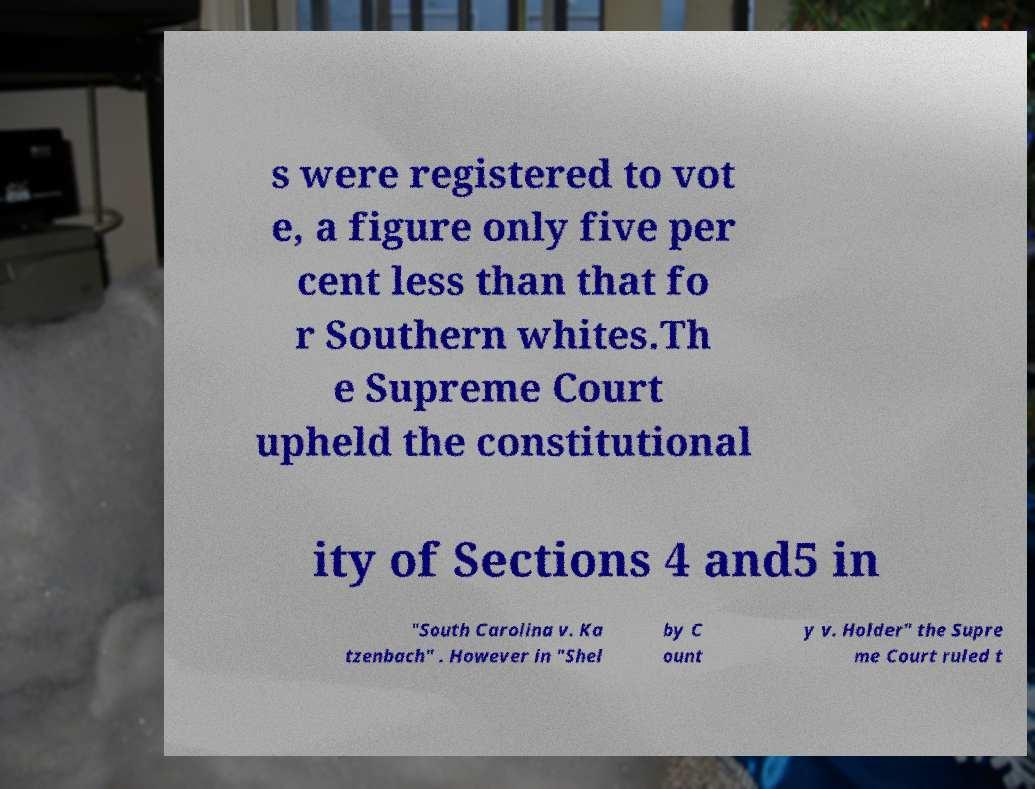Can you read and provide the text displayed in the image?This photo seems to have some interesting text. Can you extract and type it out for me? s were registered to vot e, a figure only five per cent less than that fo r Southern whites.Th e Supreme Court upheld the constitutional ity of Sections 4 and5 in "South Carolina v. Ka tzenbach" . However in "Shel by C ount y v. Holder" the Supre me Court ruled t 